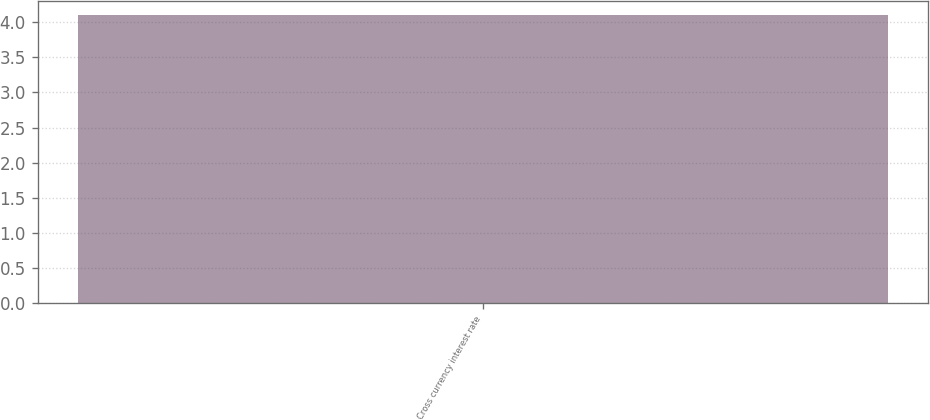Convert chart to OTSL. <chart><loc_0><loc_0><loc_500><loc_500><bar_chart><fcel>Cross currency interest rate<nl><fcel>4.1<nl></chart> 